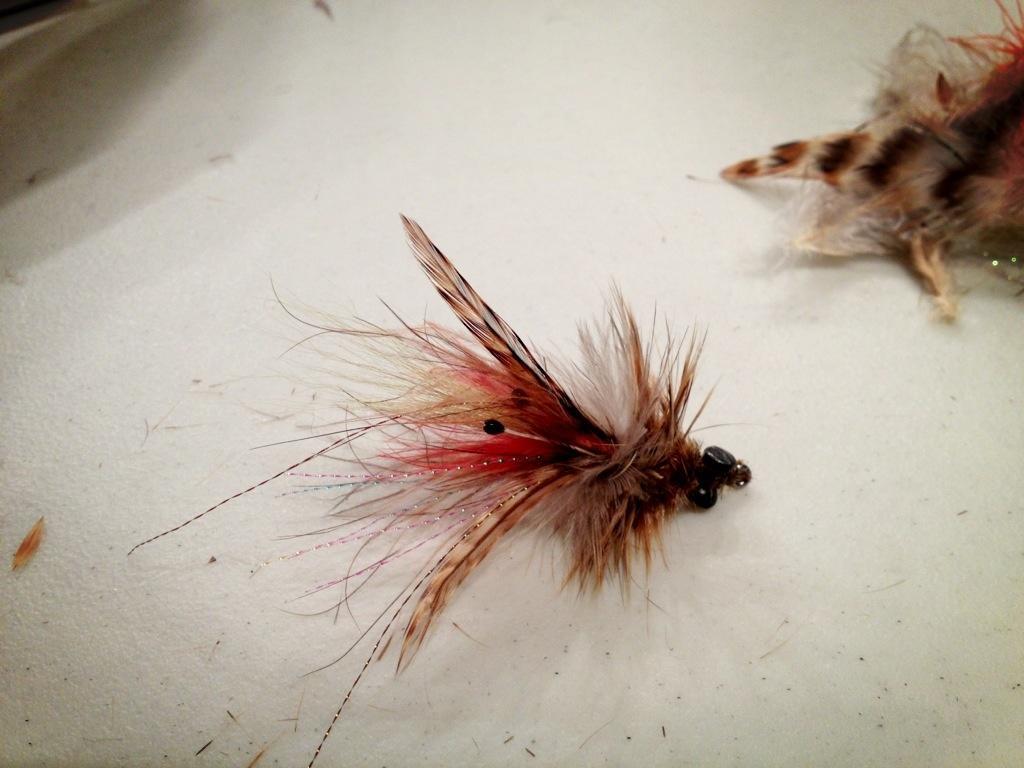Could you give a brief overview of what you see in this image? In this picture there are two artificial insects on the white color cloth. 